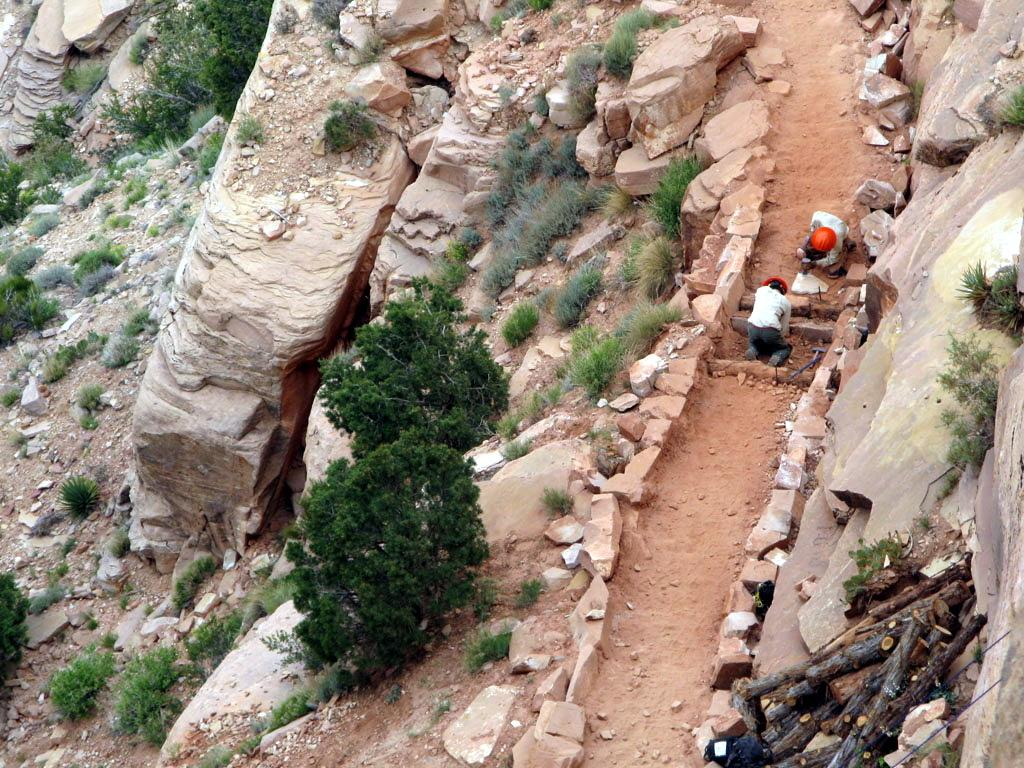What are the people in the image wearing on their heads? The people in the image are wearing helmets. What type of terrain is visible in the image? There is grass visible in the image. What type of vegetation can be seen in the image? There are plants in the image. What material are some of the objects made of in the image? There are wooden objects in the image. What type of natural elements can be seen in the image? There are stones in the image. What other objects are present on the ground in the image? There are other objects on the ground in the image. How many pigs are present in the image? There are no pigs present in the image. What type of legal advice can be sought from the people in the image? The people in the image are not depicted as lawyers or providing legal advice. 